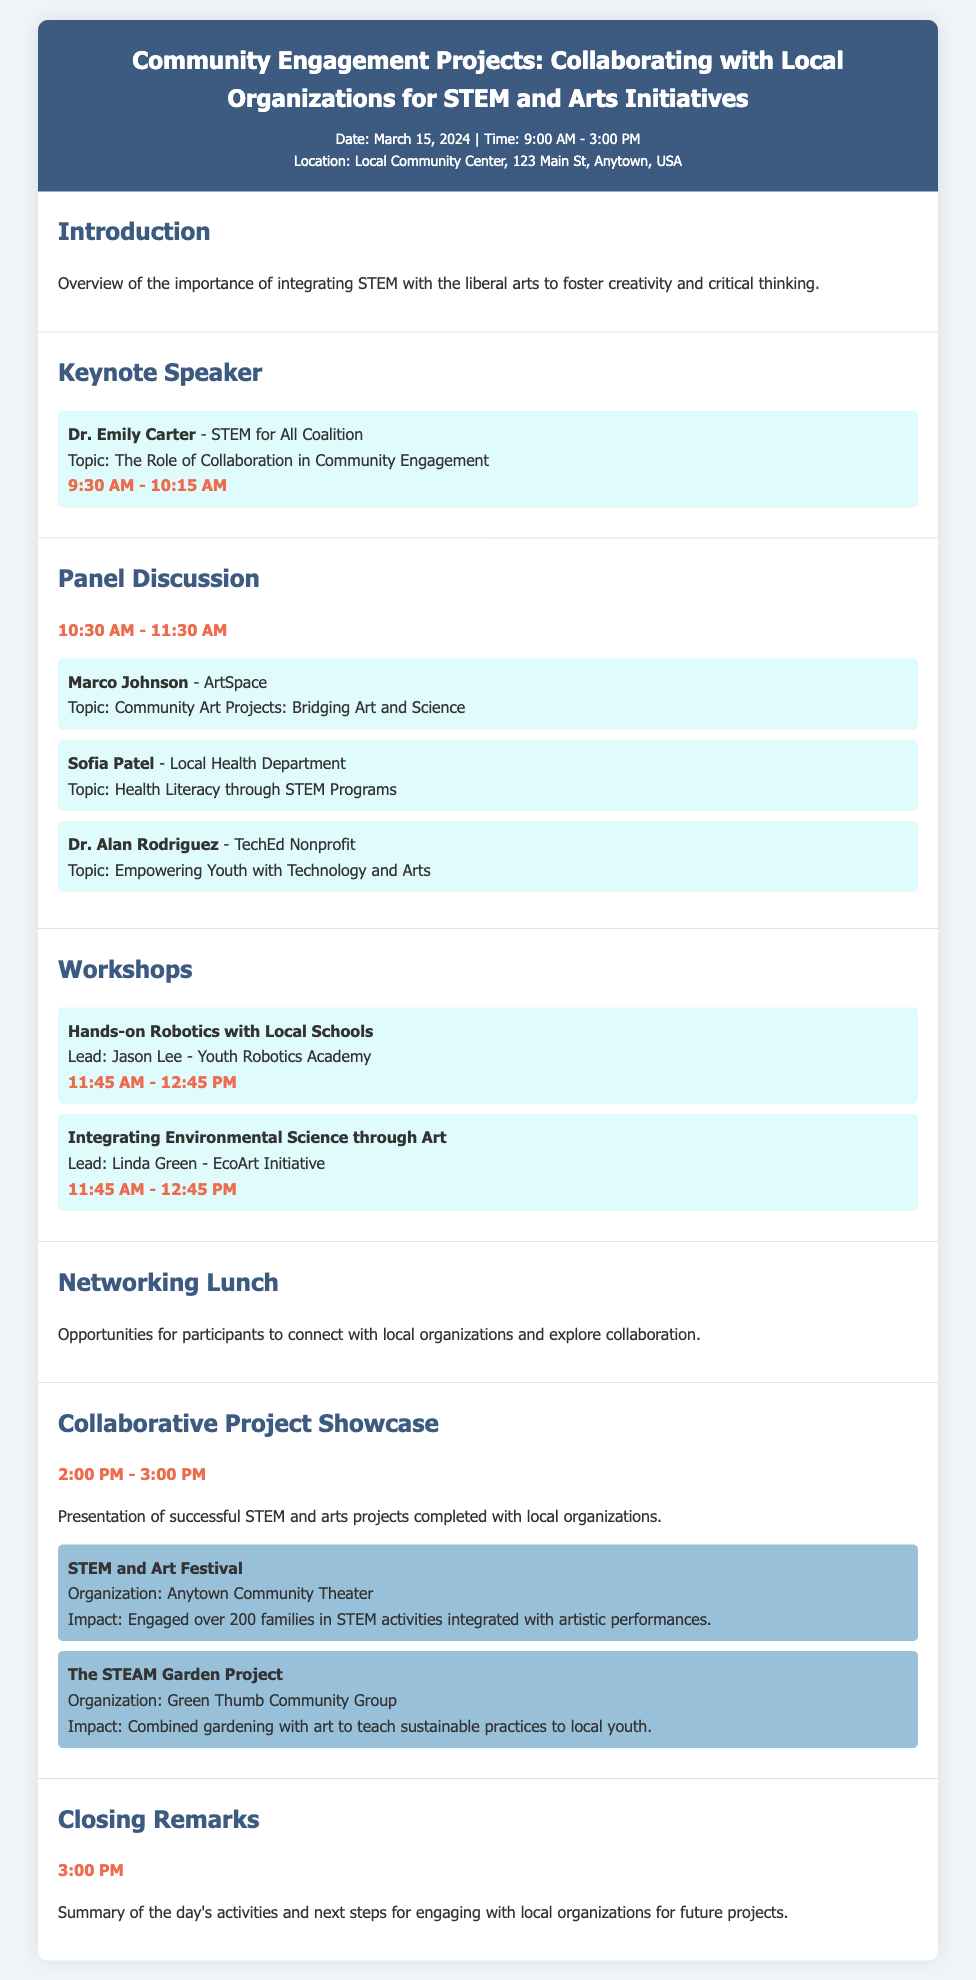What is the date of the event? The date of the event is stated at the top of the document.
Answer: March 15, 2024 Who is the keynote speaker? The document lists the keynote speaker in the designated section.
Answer: Dr. Emily Carter What is the time of the keynote speech? The time is specified below the keynote speaker's name.
Answer: 9:30 AM - 10:15 AM What organization is leading the hands-on robotics workshop? The document mentions the lead for the robotics workshop.
Answer: Youth Robotics Academy How many projects are showcased in the Collaborative Project Showcase? The number of projects can be counted from the provided section.
Answer: 2 What topic does Marco Johnson address in the panel discussion? The document specifies the topic he addresses.
Answer: Community Art Projects: Bridging Art and Science Which organization is associated with the STEAM Garden Project? The organization is mentioned in the details of the project showcase.
Answer: Green Thumb Community Group What is the time for the networking lunch? The document provides an overview but does not specify the time.
Answer: [Not specified] What is the impact of the STEM and Art Festival? The impact is described in the project showcase section.
Answer: Engaged over 200 families in STEM activities integrated with artistic performances 